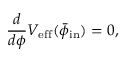Convert formula to latex. <formula><loc_0><loc_0><loc_500><loc_500>\frac { d } { d \phi } V _ { e f f } ( \bar { \phi } _ { i n } ) = 0 ,</formula> 